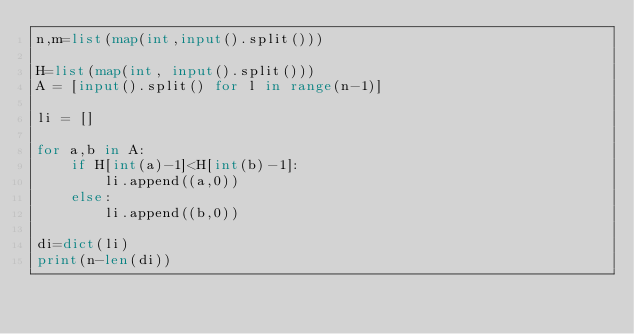Convert code to text. <code><loc_0><loc_0><loc_500><loc_500><_Python_>n,m=list(map(int,input().split()))

H=list(map(int, input().split()))
A = [input().split() for l in range(n-1)]

li = []

for a,b in A:
    if H[int(a)-1]<H[int(b)-1]:
        li.append((a,0))
    else:
        li.append((b,0))

di=dict(li)
print(n-len(di))
        </code> 